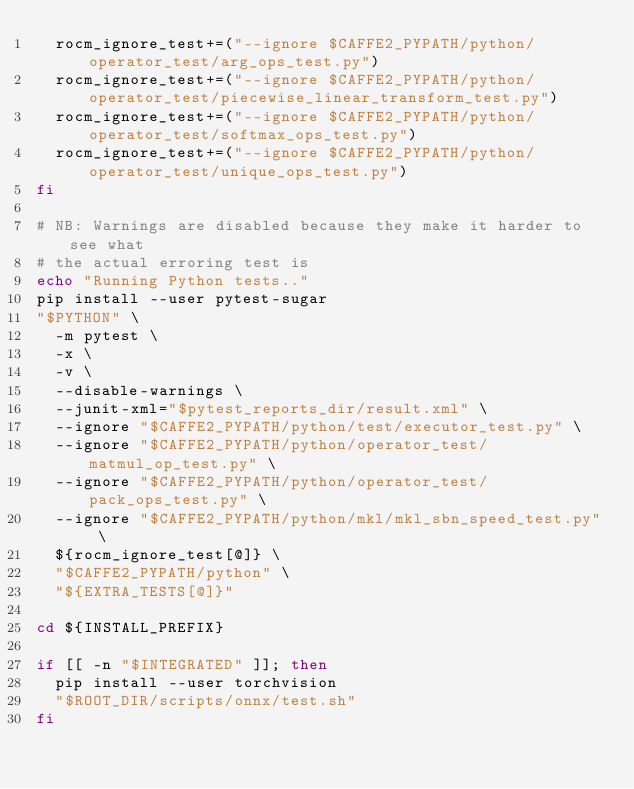<code> <loc_0><loc_0><loc_500><loc_500><_Bash_>  rocm_ignore_test+=("--ignore $CAFFE2_PYPATH/python/operator_test/arg_ops_test.py")
  rocm_ignore_test+=("--ignore $CAFFE2_PYPATH/python/operator_test/piecewise_linear_transform_test.py")
  rocm_ignore_test+=("--ignore $CAFFE2_PYPATH/python/operator_test/softmax_ops_test.py")
  rocm_ignore_test+=("--ignore $CAFFE2_PYPATH/python/operator_test/unique_ops_test.py")
fi

# NB: Warnings are disabled because they make it harder to see what
# the actual erroring test is
echo "Running Python tests.."
pip install --user pytest-sugar
"$PYTHON" \
  -m pytest \
  -x \
  -v \
  --disable-warnings \
  --junit-xml="$pytest_reports_dir/result.xml" \
  --ignore "$CAFFE2_PYPATH/python/test/executor_test.py" \
  --ignore "$CAFFE2_PYPATH/python/operator_test/matmul_op_test.py" \
  --ignore "$CAFFE2_PYPATH/python/operator_test/pack_ops_test.py" \
  --ignore "$CAFFE2_PYPATH/python/mkl/mkl_sbn_speed_test.py" \
  ${rocm_ignore_test[@]} \
  "$CAFFE2_PYPATH/python" \
  "${EXTRA_TESTS[@]}"

cd ${INSTALL_PREFIX}

if [[ -n "$INTEGRATED" ]]; then
  pip install --user torchvision
  "$ROOT_DIR/scripts/onnx/test.sh"
fi
</code> 